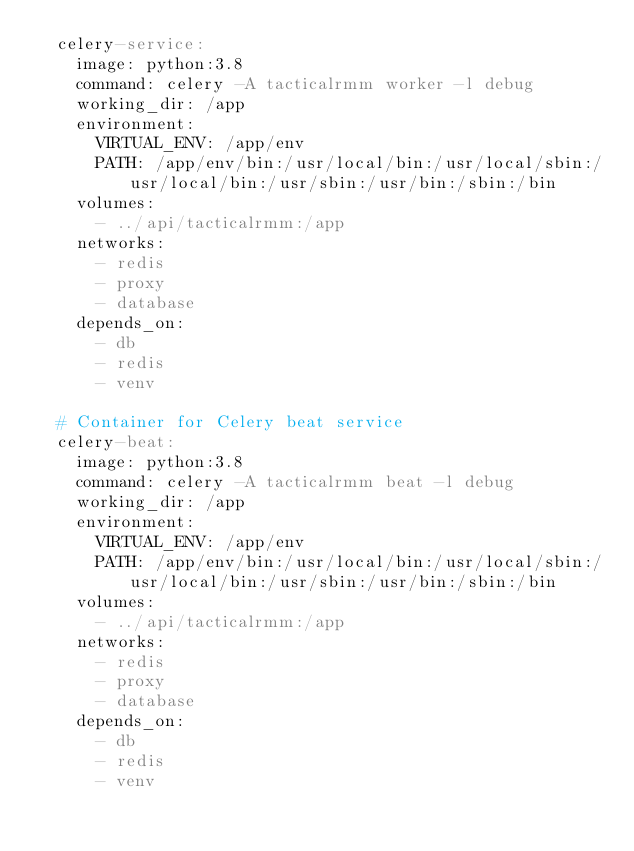Convert code to text. <code><loc_0><loc_0><loc_500><loc_500><_YAML_>  celery-service:
    image: python:3.8
    command: celery -A tacticalrmm worker -l debug
    working_dir: /app
    environment:
      VIRTUAL_ENV: /app/env
      PATH: /app/env/bin:/usr/local/bin:/usr/local/sbin:/usr/local/bin:/usr/sbin:/usr/bin:/sbin:/bin
    volumes:
      - ../api/tacticalrmm:/app
    networks:
      - redis
      - proxy
      - database
    depends_on:
      - db
      - redis
      - venv

  # Container for Celery beat service
  celery-beat:
    image: python:3.8
    command: celery -A tacticalrmm beat -l debug
    working_dir: /app
    environment:
      VIRTUAL_ENV: /app/env
      PATH: /app/env/bin:/usr/local/bin:/usr/local/sbin:/usr/local/bin:/usr/sbin:/usr/bin:/sbin:/bin
    volumes:
      - ../api/tacticalrmm:/app
    networks:
      - redis
      - proxy
      - database
    depends_on:
      - db
      - redis
      - venv
</code> 